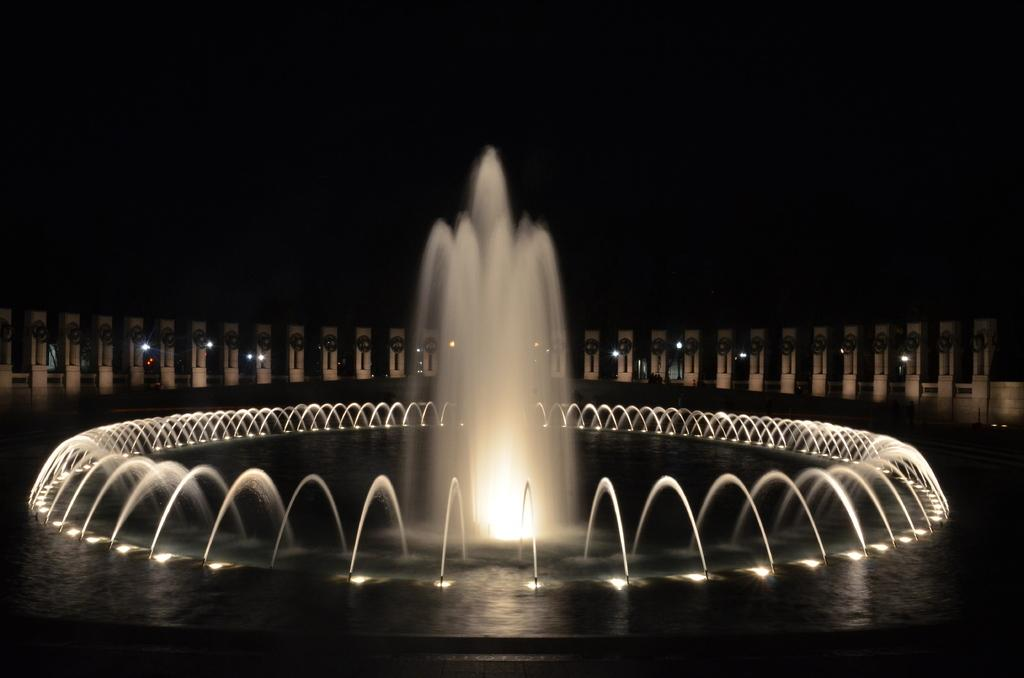What is the main feature in the image? There is a fountain in the image. What is flowing from the fountain? There is water in the fountain. Can you describe the lighting in the image? There is light present in the image. What type of plants are being used for learning in the image? There are no plants or learning activities present in the image; it features a fountain with water and light. 